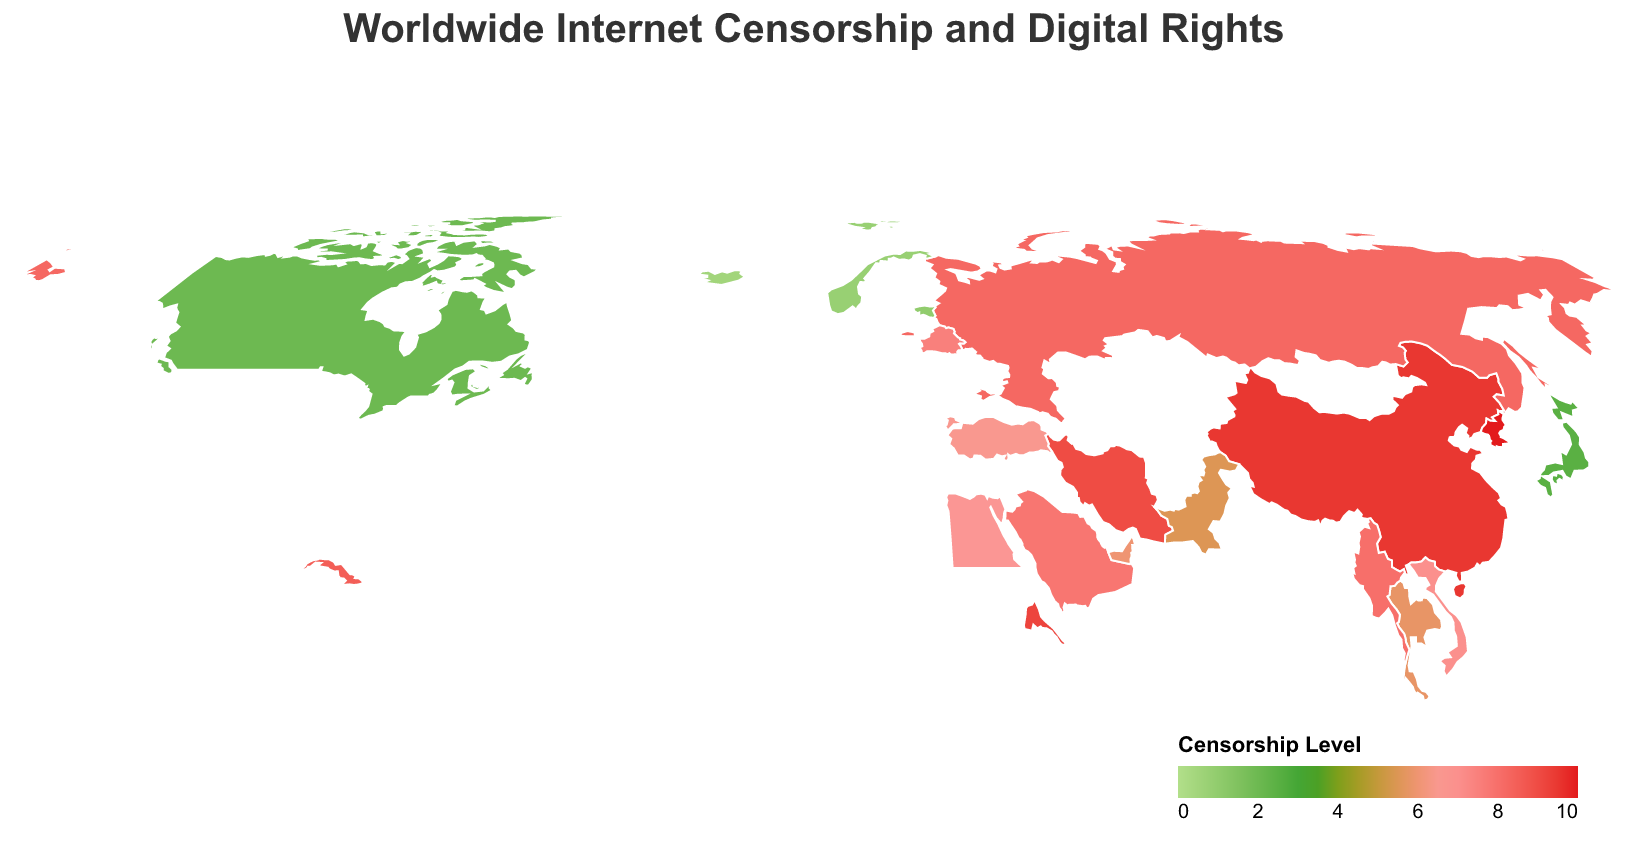What is the main restriction type in China? Look for the entry for China in the tooltip or data points and read off the main restriction type.
Answer: Content Filtering Which country has the highest censorship level? Identify the country with the darkest red shading on the map, as darker shades signify higher censorship levels.
Answer: North Korea What is the digital rights score of Estonia? Locate Estonia on the map and refer to the tooltip that appears; it will show the digital rights score.
Answer: 95 Compare the censorship levels of China and Russia. Which is higher? Find both China and Russia on the map, note their censorship levels from the tooltip and compare them.
Answer: China's censorship level is higher Which country has a censorship level closest to 7.0? Examine the countries with medium red shading and check their tooltip or data values to find the one with a censorship level closest to 7.0.
Answer: Vietnam How does the digital rights score of Canada compare to that of Japan? Find the digital rights scores for both Canada and Japan in the tooltips and compare them.
Answer: Canada's digital rights score is higher than Japan's What type of internet restriction is most commonly observed among countries with high censorship levels? Look at the tooltip data for countries with the darkest red shades and note the common restriction types.
Answer: Common types include Content Filtering, Total Internet Control, and Internet Shutdowns What is the average censorship level for the countries listed? Sum up all the censorship levels from the data points and divide by the number of countries. (i.e., (9.5 + 8.2 + 9.0 + 10.0 + 7.8 + 6.5 + 7.0 + 8.5 + 6.8 + 6.0 + 5.5 + 5.8 + 7.5 + 8.0 + 9.2 + 1.0 + 0.5 + 0.8 + 2.0 + 2.5) / 20)
Answer: 6.3 Which country in the figure has the highest digital rights score and what does it indicate? Identify the country with the highest digital rights score from the tooltip and interpret it.
Answer: Iceland; it indicates the least censorship and most open internet 